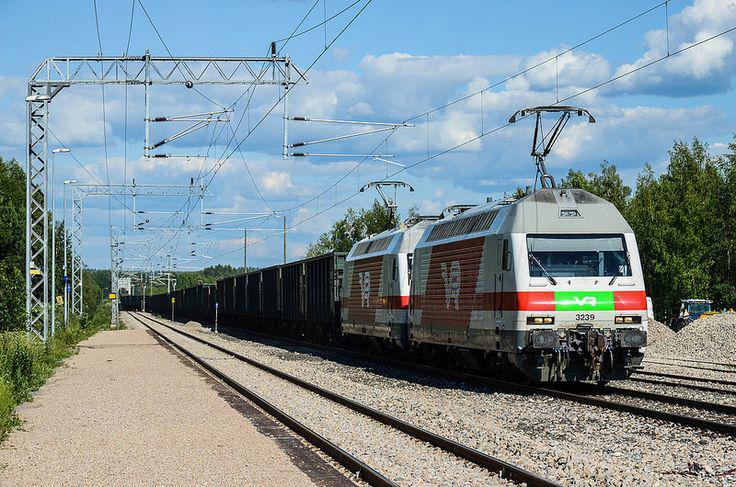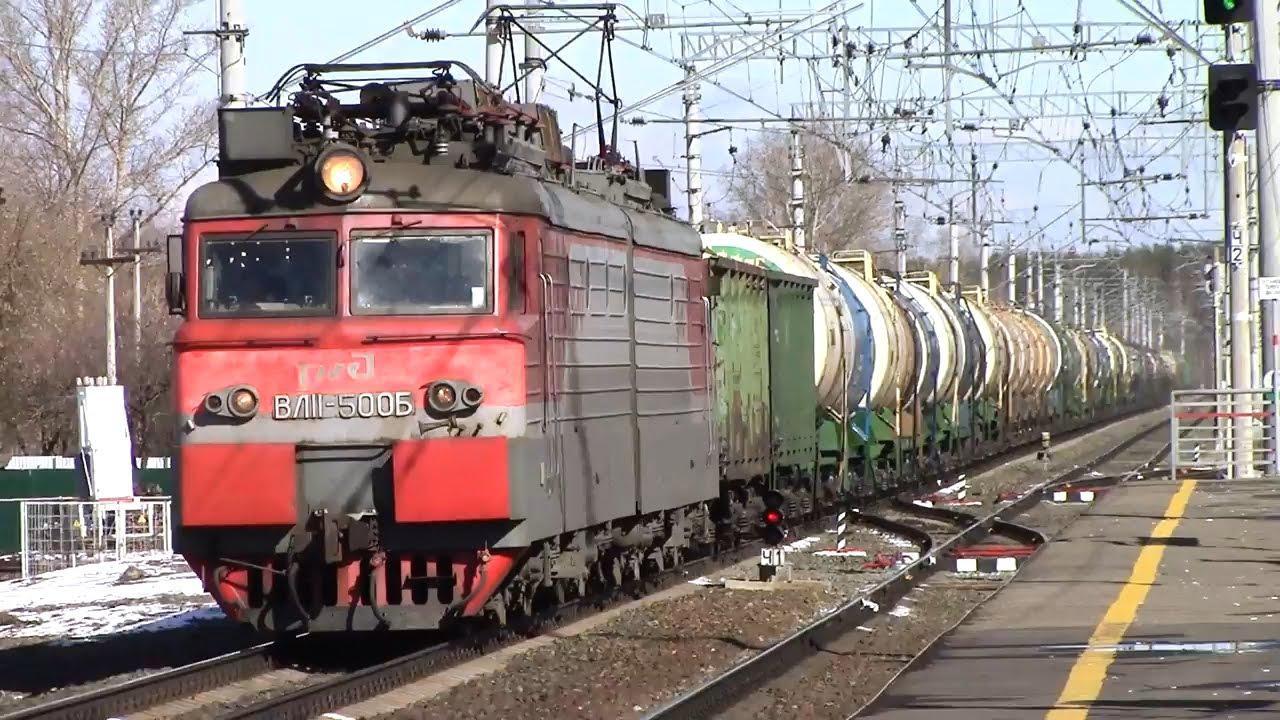The first image is the image on the left, the second image is the image on the right. Given the left and right images, does the statement "At least one image shows a green train with red-orange trim pulling a line of freight cars." hold true? Answer yes or no. No. 